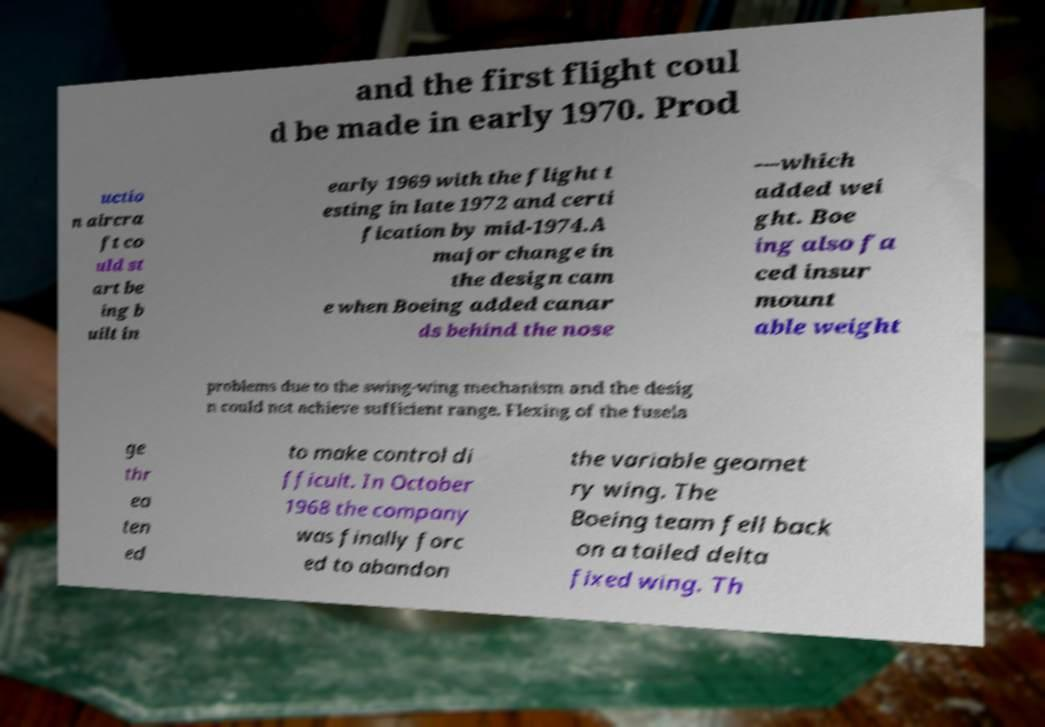Could you extract and type out the text from this image? and the first flight coul d be made in early 1970. Prod uctio n aircra ft co uld st art be ing b uilt in early 1969 with the flight t esting in late 1972 and certi fication by mid-1974.A major change in the design cam e when Boeing added canar ds behind the nose —which added wei ght. Boe ing also fa ced insur mount able weight problems due to the swing-wing mechanism and the desig n could not achieve sufficient range. Flexing of the fusela ge thr ea ten ed to make control di fficult. In October 1968 the company was finally forc ed to abandon the variable geomet ry wing. The Boeing team fell back on a tailed delta fixed wing. Th 